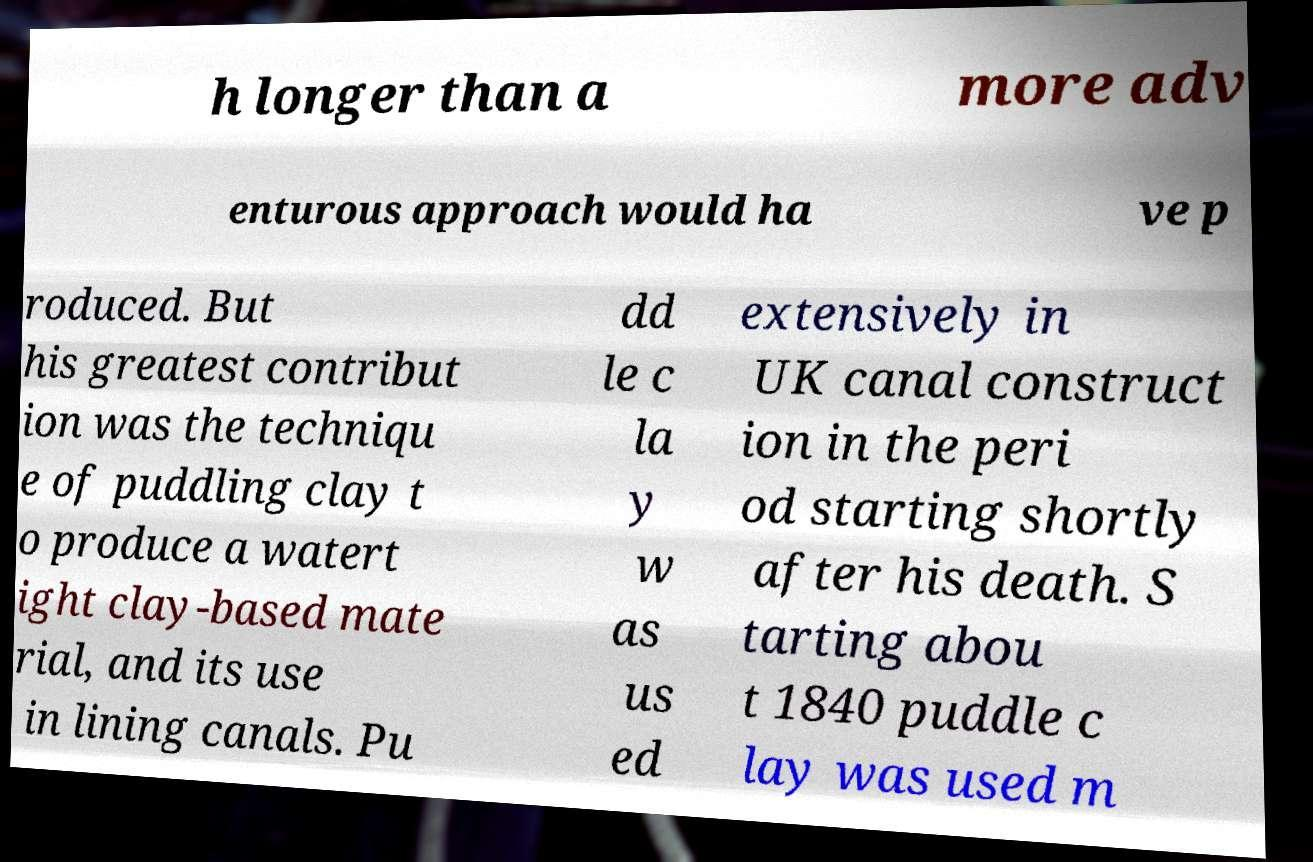Can you read and provide the text displayed in the image?This photo seems to have some interesting text. Can you extract and type it out for me? h longer than a more adv enturous approach would ha ve p roduced. But his greatest contribut ion was the techniqu e of puddling clay t o produce a watert ight clay-based mate rial, and its use in lining canals. Pu dd le c la y w as us ed extensively in UK canal construct ion in the peri od starting shortly after his death. S tarting abou t 1840 puddle c lay was used m 